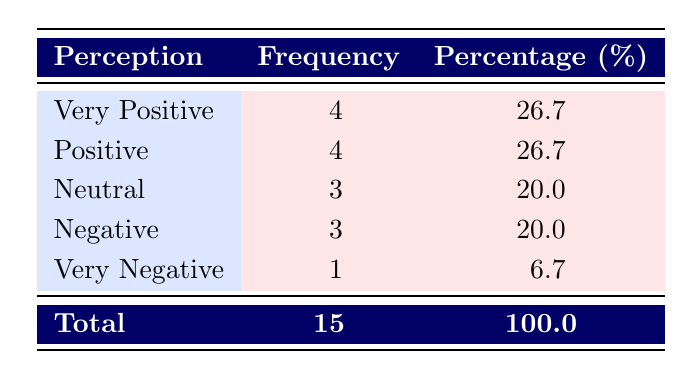What is the frequency of respondents who have a negative perception? There are 3 respondents who reported having a negative perception. This can be directly seen under the "Frequency" column for the "Negative" perception row.
Answer: 3 How many respondents had a very positive or positive perception? To find the total, we sum the frequencies of "Very Positive" (4) and "Positive" (4), resulting in 4 + 4 = 8 respondents. This is derived from the respective rows listed.
Answer: 8 What percentage of respondents rated their perception as very negative? The percentage for "Very Negative" is given directly in the table as 6.7%, which refers to the number of respondents who felt that way compared to the total.
Answer: 6.7% Is the majority of respondents perceiving non-Western political thought in a positive light? Yes, there are a total of 8 positive perceptions (4 very positive and 4 positive) out of 15 total respondents. Since 8 out of 15 is greater than half, it indicates that a majority have a positive perception.
Answer: Yes What is the difference in the number of respondents having a very positive perception and those with a neutral perception? The very positive perception has a frequency of 4, and the neutral perception has a frequency of 3. The difference is calculated as 4 - 3 = 1. This shows that 1 more respondent viewed non-Western political thought very positively compared to those who felt neutral.
Answer: 1 How many perceptions fall into the neutral and very negative categories combined? Adding the frequencies for "Neutral" (3) and "Very Negative" (1) gives a total of 3 + 1 = 4 respondents falling into these categories.
Answer: 4 What proportion of the total respondents expressed either a neutral or negative perception? The total respondents expressing neutral perceptions (3) and negative perceptions (3) is 6. To find the proportion, divide 6 by the total respondents (15): 6/15 = 0.4 or 40%.
Answer: 40% Was there any respondent from Canada who had a very positive perception? Yes, one respondent from Canada rated their perception as very positive, and this is indicated by the entry for respondent 11 in the table.
Answer: Yes What is the highest percentage of perception recorded in the survey? The highest percentages are for "Very Positive" and "Positive," both at 26.7%. These values are found in the table under their respective perception categories.
Answer: 26.7% 